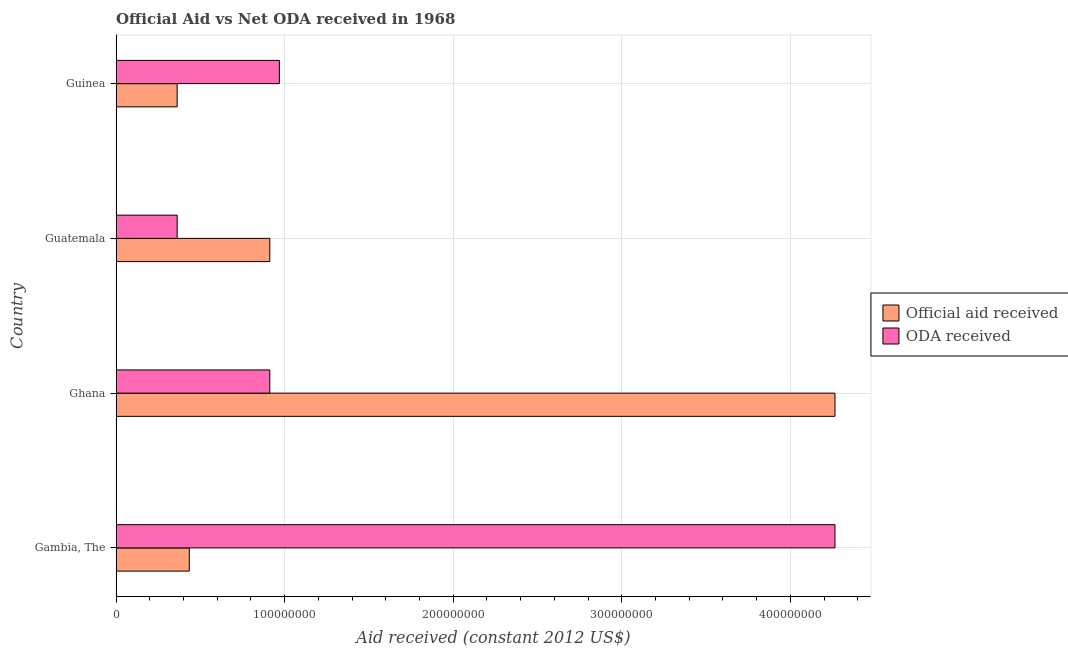How many different coloured bars are there?
Give a very brief answer. 2. Are the number of bars per tick equal to the number of legend labels?
Ensure brevity in your answer.  Yes. Are the number of bars on each tick of the Y-axis equal?
Offer a very short reply. Yes. What is the label of the 2nd group of bars from the top?
Your answer should be very brief. Guatemala. In how many cases, is the number of bars for a given country not equal to the number of legend labels?
Offer a very short reply. 0. What is the official aid received in Guatemala?
Your response must be concise. 9.12e+07. Across all countries, what is the maximum oda received?
Ensure brevity in your answer.  4.26e+08. Across all countries, what is the minimum official aid received?
Ensure brevity in your answer.  3.62e+07. In which country was the oda received maximum?
Offer a terse response. Gambia, The. In which country was the official aid received minimum?
Provide a succinct answer. Guinea. What is the total oda received in the graph?
Your answer should be very brief. 6.51e+08. What is the difference between the oda received in Ghana and that in Guinea?
Provide a succinct answer. -5.68e+06. What is the difference between the official aid received in Ghana and the oda received in Guinea?
Your answer should be compact. 3.30e+08. What is the average oda received per country?
Provide a short and direct response. 1.63e+08. What is the difference between the official aid received and oda received in Ghana?
Provide a succinct answer. 3.35e+08. What is the ratio of the official aid received in Ghana to that in Guinea?
Ensure brevity in your answer.  11.78. What is the difference between the highest and the second highest official aid received?
Your answer should be very brief. 3.35e+08. What is the difference between the highest and the lowest oda received?
Provide a short and direct response. 3.90e+08. In how many countries, is the official aid received greater than the average official aid received taken over all countries?
Offer a terse response. 1. What does the 1st bar from the top in Guinea represents?
Your answer should be compact. ODA received. What does the 1st bar from the bottom in Guinea represents?
Offer a very short reply. Official aid received. How many bars are there?
Provide a short and direct response. 8. Are all the bars in the graph horizontal?
Your answer should be very brief. Yes. How many countries are there in the graph?
Your answer should be compact. 4. Where does the legend appear in the graph?
Offer a very short reply. Center right. How are the legend labels stacked?
Offer a very short reply. Vertical. What is the title of the graph?
Make the answer very short. Official Aid vs Net ODA received in 1968 . Does "National Visitors" appear as one of the legend labels in the graph?
Your answer should be very brief. No. What is the label or title of the X-axis?
Provide a short and direct response. Aid received (constant 2012 US$). What is the Aid received (constant 2012 US$) in Official aid received in Gambia, The?
Give a very brief answer. 4.34e+07. What is the Aid received (constant 2012 US$) in ODA received in Gambia, The?
Offer a very short reply. 4.26e+08. What is the Aid received (constant 2012 US$) in Official aid received in Ghana?
Make the answer very short. 4.26e+08. What is the Aid received (constant 2012 US$) in ODA received in Ghana?
Provide a succinct answer. 9.12e+07. What is the Aid received (constant 2012 US$) of Official aid received in Guatemala?
Your answer should be compact. 9.12e+07. What is the Aid received (constant 2012 US$) of ODA received in Guatemala?
Your answer should be compact. 3.62e+07. What is the Aid received (constant 2012 US$) of Official aid received in Guinea?
Provide a short and direct response. 3.62e+07. What is the Aid received (constant 2012 US$) in ODA received in Guinea?
Your answer should be very brief. 9.68e+07. Across all countries, what is the maximum Aid received (constant 2012 US$) of Official aid received?
Make the answer very short. 4.26e+08. Across all countries, what is the maximum Aid received (constant 2012 US$) of ODA received?
Make the answer very short. 4.26e+08. Across all countries, what is the minimum Aid received (constant 2012 US$) of Official aid received?
Provide a succinct answer. 3.62e+07. Across all countries, what is the minimum Aid received (constant 2012 US$) of ODA received?
Make the answer very short. 3.62e+07. What is the total Aid received (constant 2012 US$) of Official aid received in the graph?
Offer a terse response. 5.97e+08. What is the total Aid received (constant 2012 US$) of ODA received in the graph?
Ensure brevity in your answer.  6.51e+08. What is the difference between the Aid received (constant 2012 US$) in Official aid received in Gambia, The and that in Ghana?
Ensure brevity in your answer.  -3.83e+08. What is the difference between the Aid received (constant 2012 US$) in ODA received in Gambia, The and that in Ghana?
Offer a very short reply. 3.35e+08. What is the difference between the Aid received (constant 2012 US$) in Official aid received in Gambia, The and that in Guatemala?
Give a very brief answer. -4.78e+07. What is the difference between the Aid received (constant 2012 US$) in ODA received in Gambia, The and that in Guatemala?
Provide a short and direct response. 3.90e+08. What is the difference between the Aid received (constant 2012 US$) in Official aid received in Gambia, The and that in Guinea?
Provide a succinct answer. 7.20e+06. What is the difference between the Aid received (constant 2012 US$) in ODA received in Gambia, The and that in Guinea?
Make the answer very short. 3.30e+08. What is the difference between the Aid received (constant 2012 US$) of Official aid received in Ghana and that in Guatemala?
Offer a terse response. 3.35e+08. What is the difference between the Aid received (constant 2012 US$) of ODA received in Ghana and that in Guatemala?
Provide a short and direct response. 5.50e+07. What is the difference between the Aid received (constant 2012 US$) in Official aid received in Ghana and that in Guinea?
Provide a succinct answer. 3.90e+08. What is the difference between the Aid received (constant 2012 US$) of ODA received in Ghana and that in Guinea?
Your answer should be very brief. -5.68e+06. What is the difference between the Aid received (constant 2012 US$) in Official aid received in Guatemala and that in Guinea?
Make the answer very short. 5.50e+07. What is the difference between the Aid received (constant 2012 US$) in ODA received in Guatemala and that in Guinea?
Offer a very short reply. -6.06e+07. What is the difference between the Aid received (constant 2012 US$) in Official aid received in Gambia, The and the Aid received (constant 2012 US$) in ODA received in Ghana?
Ensure brevity in your answer.  -4.78e+07. What is the difference between the Aid received (constant 2012 US$) in Official aid received in Gambia, The and the Aid received (constant 2012 US$) in ODA received in Guatemala?
Offer a very short reply. 7.20e+06. What is the difference between the Aid received (constant 2012 US$) in Official aid received in Gambia, The and the Aid received (constant 2012 US$) in ODA received in Guinea?
Provide a short and direct response. -5.34e+07. What is the difference between the Aid received (constant 2012 US$) of Official aid received in Ghana and the Aid received (constant 2012 US$) of ODA received in Guatemala?
Your answer should be compact. 3.90e+08. What is the difference between the Aid received (constant 2012 US$) in Official aid received in Ghana and the Aid received (constant 2012 US$) in ODA received in Guinea?
Provide a short and direct response. 3.30e+08. What is the difference between the Aid received (constant 2012 US$) of Official aid received in Guatemala and the Aid received (constant 2012 US$) of ODA received in Guinea?
Give a very brief answer. -5.68e+06. What is the average Aid received (constant 2012 US$) of Official aid received per country?
Provide a succinct answer. 1.49e+08. What is the average Aid received (constant 2012 US$) in ODA received per country?
Give a very brief answer. 1.63e+08. What is the difference between the Aid received (constant 2012 US$) of Official aid received and Aid received (constant 2012 US$) of ODA received in Gambia, The?
Ensure brevity in your answer.  -3.83e+08. What is the difference between the Aid received (constant 2012 US$) in Official aid received and Aid received (constant 2012 US$) in ODA received in Ghana?
Give a very brief answer. 3.35e+08. What is the difference between the Aid received (constant 2012 US$) of Official aid received and Aid received (constant 2012 US$) of ODA received in Guatemala?
Your answer should be compact. 5.50e+07. What is the difference between the Aid received (constant 2012 US$) of Official aid received and Aid received (constant 2012 US$) of ODA received in Guinea?
Keep it short and to the point. -6.06e+07. What is the ratio of the Aid received (constant 2012 US$) of Official aid received in Gambia, The to that in Ghana?
Your answer should be compact. 0.1. What is the ratio of the Aid received (constant 2012 US$) in ODA received in Gambia, The to that in Ghana?
Your answer should be very brief. 4.68. What is the ratio of the Aid received (constant 2012 US$) of Official aid received in Gambia, The to that in Guatemala?
Provide a succinct answer. 0.48. What is the ratio of the Aid received (constant 2012 US$) of ODA received in Gambia, The to that in Guatemala?
Offer a terse response. 11.78. What is the ratio of the Aid received (constant 2012 US$) of Official aid received in Gambia, The to that in Guinea?
Ensure brevity in your answer.  1.2. What is the ratio of the Aid received (constant 2012 US$) of ODA received in Gambia, The to that in Guinea?
Your answer should be very brief. 4.4. What is the ratio of the Aid received (constant 2012 US$) in Official aid received in Ghana to that in Guatemala?
Offer a terse response. 4.68. What is the ratio of the Aid received (constant 2012 US$) of ODA received in Ghana to that in Guatemala?
Offer a terse response. 2.52. What is the ratio of the Aid received (constant 2012 US$) in Official aid received in Ghana to that in Guinea?
Offer a terse response. 11.78. What is the ratio of the Aid received (constant 2012 US$) of ODA received in Ghana to that in Guinea?
Your answer should be compact. 0.94. What is the ratio of the Aid received (constant 2012 US$) of Official aid received in Guatemala to that in Guinea?
Offer a terse response. 2.52. What is the ratio of the Aid received (constant 2012 US$) in ODA received in Guatemala to that in Guinea?
Make the answer very short. 0.37. What is the difference between the highest and the second highest Aid received (constant 2012 US$) in Official aid received?
Provide a succinct answer. 3.35e+08. What is the difference between the highest and the second highest Aid received (constant 2012 US$) in ODA received?
Ensure brevity in your answer.  3.30e+08. What is the difference between the highest and the lowest Aid received (constant 2012 US$) in Official aid received?
Give a very brief answer. 3.90e+08. What is the difference between the highest and the lowest Aid received (constant 2012 US$) in ODA received?
Keep it short and to the point. 3.90e+08. 